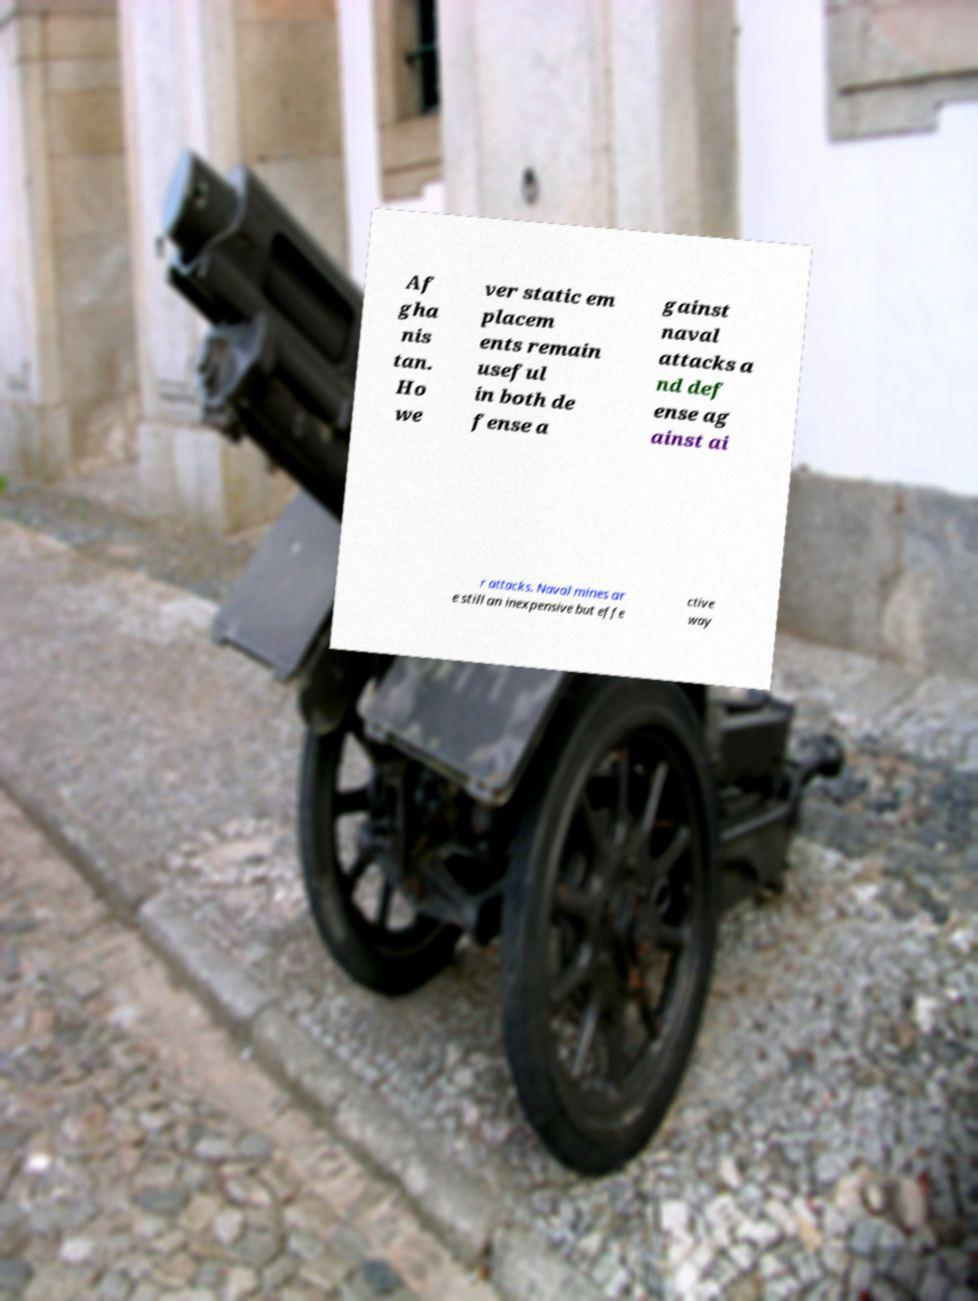For documentation purposes, I need the text within this image transcribed. Could you provide that? Af gha nis tan. Ho we ver static em placem ents remain useful in both de fense a gainst naval attacks a nd def ense ag ainst ai r attacks. Naval mines ar e still an inexpensive but effe ctive way 